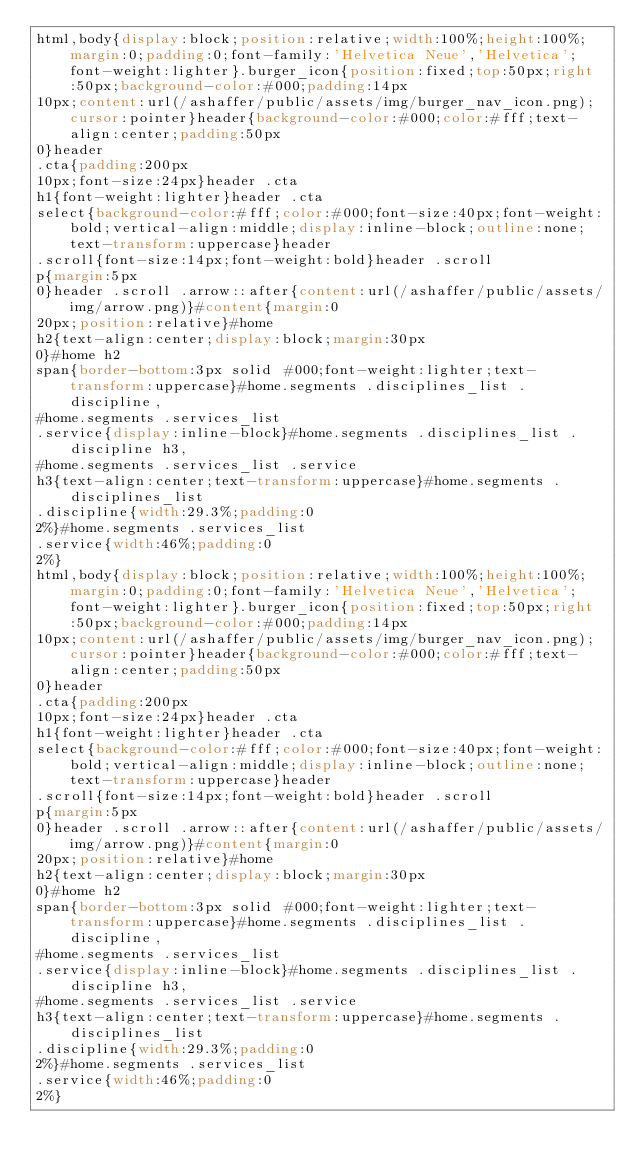<code> <loc_0><loc_0><loc_500><loc_500><_CSS_>html,body{display:block;position:relative;width:100%;height:100%;margin:0;padding:0;font-family:'Helvetica Neue','Helvetica';font-weight:lighter}.burger_icon{position:fixed;top:50px;right:50px;background-color:#000;padding:14px
10px;content:url(/ashaffer/public/assets/img/burger_nav_icon.png);cursor:pointer}header{background-color:#000;color:#fff;text-align:center;padding:50px
0}header
.cta{padding:200px
10px;font-size:24px}header .cta
h1{font-weight:lighter}header .cta
select{background-color:#fff;color:#000;font-size:40px;font-weight:bold;vertical-align:middle;display:inline-block;outline:none;text-transform:uppercase}header
.scroll{font-size:14px;font-weight:bold}header .scroll
p{margin:5px
0}header .scroll .arrow::after{content:url(/ashaffer/public/assets/img/arrow.png)}#content{margin:0
20px;position:relative}#home
h2{text-align:center;display:block;margin:30px
0}#home h2
span{border-bottom:3px solid #000;font-weight:lighter;text-transform:uppercase}#home.segments .disciplines_list .discipline,
#home.segments .services_list
.service{display:inline-block}#home.segments .disciplines_list .discipline h3,
#home.segments .services_list .service
h3{text-align:center;text-transform:uppercase}#home.segments .disciplines_list
.discipline{width:29.3%;padding:0
2%}#home.segments .services_list
.service{width:46%;padding:0
2%}
html,body{display:block;position:relative;width:100%;height:100%;margin:0;padding:0;font-family:'Helvetica Neue','Helvetica';font-weight:lighter}.burger_icon{position:fixed;top:50px;right:50px;background-color:#000;padding:14px
10px;content:url(/ashaffer/public/assets/img/burger_nav_icon.png);cursor:pointer}header{background-color:#000;color:#fff;text-align:center;padding:50px
0}header
.cta{padding:200px
10px;font-size:24px}header .cta
h1{font-weight:lighter}header .cta
select{background-color:#fff;color:#000;font-size:40px;font-weight:bold;vertical-align:middle;display:inline-block;outline:none;text-transform:uppercase}header
.scroll{font-size:14px;font-weight:bold}header .scroll
p{margin:5px
0}header .scroll .arrow::after{content:url(/ashaffer/public/assets/img/arrow.png)}#content{margin:0
20px;position:relative}#home
h2{text-align:center;display:block;margin:30px
0}#home h2
span{border-bottom:3px solid #000;font-weight:lighter;text-transform:uppercase}#home.segments .disciplines_list .discipline,
#home.segments .services_list
.service{display:inline-block}#home.segments .disciplines_list .discipline h3,
#home.segments .services_list .service
h3{text-align:center;text-transform:uppercase}#home.segments .disciplines_list
.discipline{width:29.3%;padding:0
2%}#home.segments .services_list
.service{width:46%;padding:0
2%}
</code> 